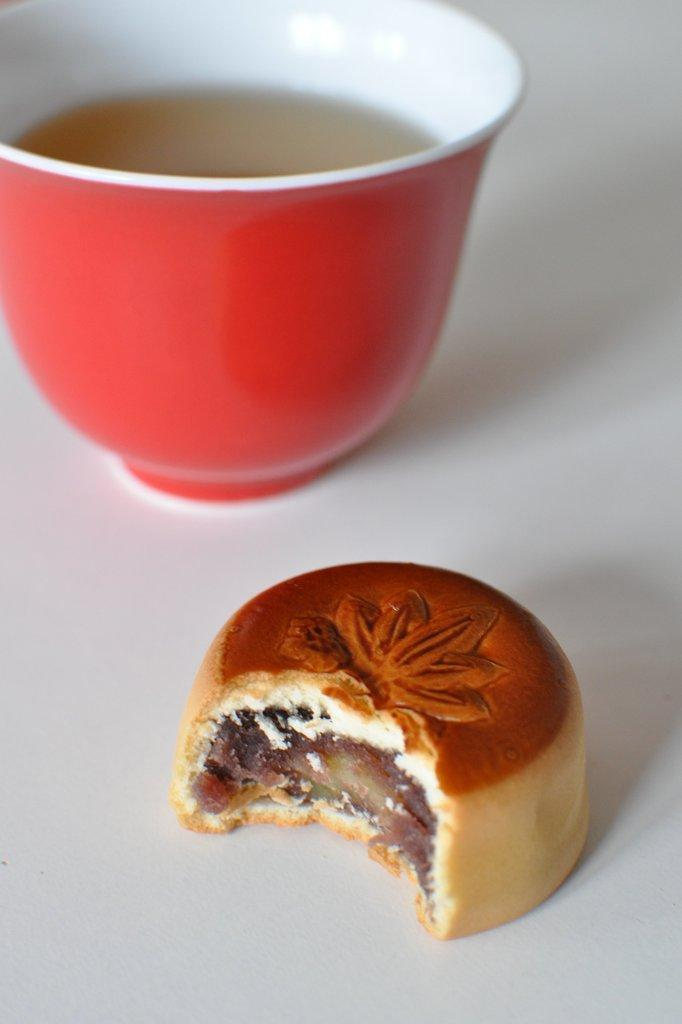What type of food can be seen in the image? The image contains food, but the specific type is not mentioned in the facts. What color is the cup in the image? The cup in the image is red. What is the cup placed on? The red cup is on a white surface. What is inside the red cup? There is liquid in the red cup. How many dolls are sitting on the edge of the red cup? There are no dolls present in the image. What sound does the bell make when it is rung in the image? There is no bell present in the image. 